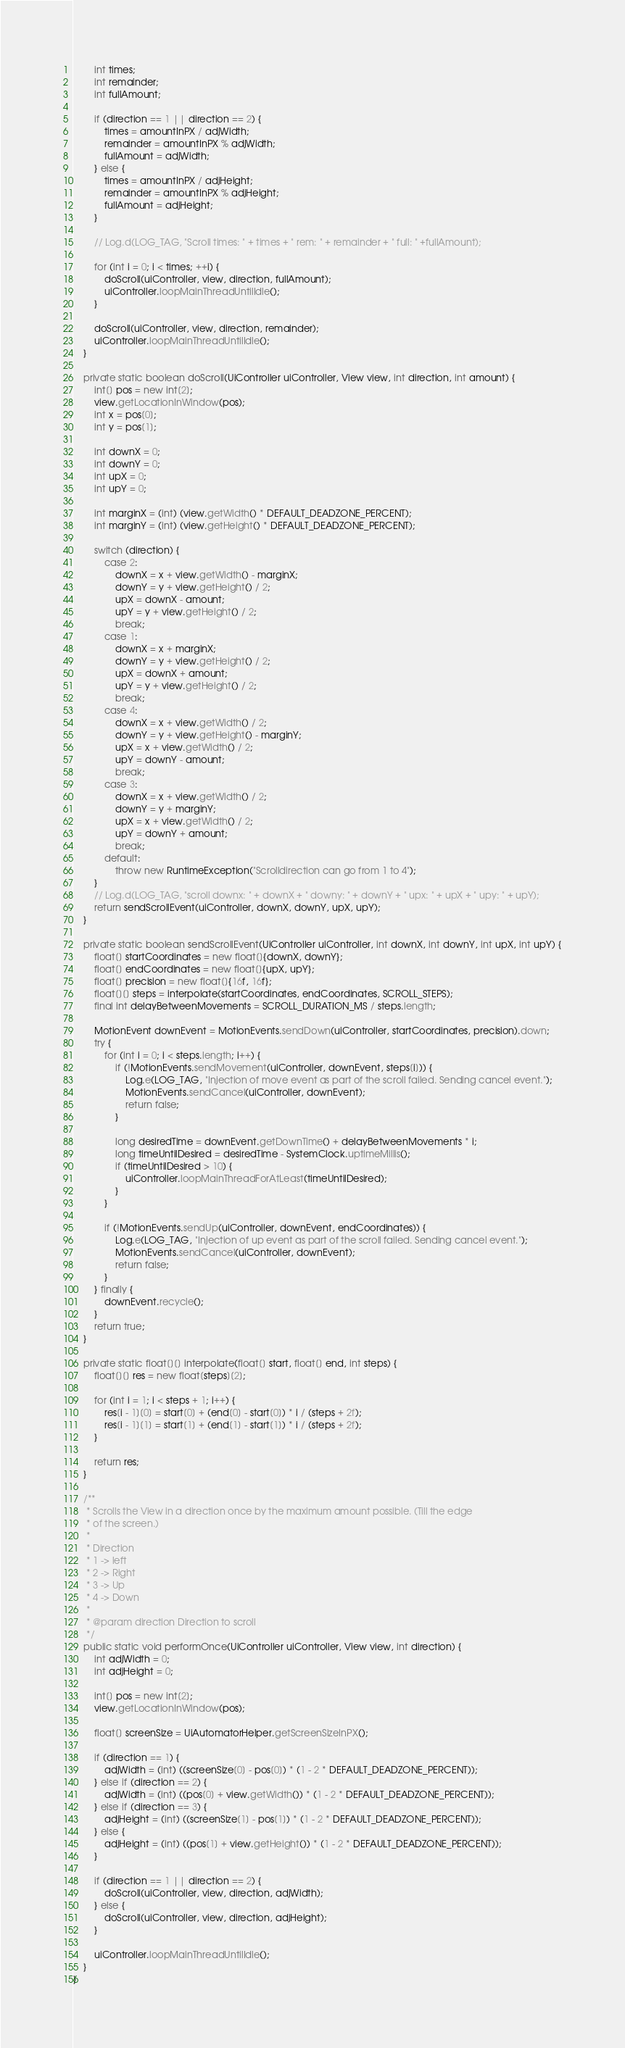Convert code to text. <code><loc_0><loc_0><loc_500><loc_500><_Java_>        int times;
        int remainder;
        int fullAmount;

        if (direction == 1 || direction == 2) {
            times = amountInPX / adjWidth;
            remainder = amountInPX % adjWidth;
            fullAmount = adjWidth;
        } else {
            times = amountInPX / adjHeight;
            remainder = amountInPX % adjHeight;
            fullAmount = adjHeight;
        }

        // Log.d(LOG_TAG, "Scroll times: " + times + " rem: " + remainder + " full: " +fullAmount);

        for (int i = 0; i < times; ++i) {
            doScroll(uiController, view, direction, fullAmount);
            uiController.loopMainThreadUntilIdle();
        }

        doScroll(uiController, view, direction, remainder);
        uiController.loopMainThreadUntilIdle();
    }

    private static boolean doScroll(UiController uiController, View view, int direction, int amount) {
        int[] pos = new int[2];
        view.getLocationInWindow(pos);
        int x = pos[0];
        int y = pos[1];

        int downX = 0;
        int downY = 0;
        int upX = 0;
        int upY = 0;

        int marginX = (int) (view.getWidth() * DEFAULT_DEADZONE_PERCENT);
        int marginY = (int) (view.getHeight() * DEFAULT_DEADZONE_PERCENT);

        switch (direction) {
            case 2:
                downX = x + view.getWidth() - marginX;
                downY = y + view.getHeight() / 2;
                upX = downX - amount;
                upY = y + view.getHeight() / 2;
                break;
            case 1:
                downX = x + marginX;
                downY = y + view.getHeight() / 2;
                upX = downX + amount;
                upY = y + view.getHeight() / 2;
                break;
            case 4:
                downX = x + view.getWidth() / 2;
                downY = y + view.getHeight() - marginY;
                upX = x + view.getWidth() / 2;
                upY = downY - amount;
                break;
            case 3:
                downX = x + view.getWidth() / 2;
                downY = y + marginY;
                upX = x + view.getWidth() / 2;
                upY = downY + amount;
                break;
            default:
                throw new RuntimeException("Scrolldirection can go from 1 to 4");
        }
        // Log.d(LOG_TAG, "scroll downx: " + downX + " downy: " + downY + " upx: " + upX + " upy: " + upY);
        return sendScrollEvent(uiController, downX, downY, upX, upY);
    }

    private static boolean sendScrollEvent(UiController uiController, int downX, int downY, int upX, int upY) {
        float[] startCoordinates = new float[]{downX, downY};
        float[] endCoordinates = new float[]{upX, upY};
        float[] precision = new float[]{16f, 16f};
        float[][] steps = interpolate(startCoordinates, endCoordinates, SCROLL_STEPS);
        final int delayBetweenMovements = SCROLL_DURATION_MS / steps.length;

        MotionEvent downEvent = MotionEvents.sendDown(uiController, startCoordinates, precision).down;
        try {
            for (int i = 0; i < steps.length; i++) {
                if (!MotionEvents.sendMovement(uiController, downEvent, steps[i])) {
                    Log.e(LOG_TAG, "Injection of move event as part of the scroll failed. Sending cancel event.");
                    MotionEvents.sendCancel(uiController, downEvent);
                    return false;
                }

                long desiredTime = downEvent.getDownTime() + delayBetweenMovements * i;
                long timeUntilDesired = desiredTime - SystemClock.uptimeMillis();
                if (timeUntilDesired > 10) {
                    uiController.loopMainThreadForAtLeast(timeUntilDesired);
                }
            }

            if (!MotionEvents.sendUp(uiController, downEvent, endCoordinates)) {
                Log.e(LOG_TAG, "Injection of up event as part of the scroll failed. Sending cancel event.");
                MotionEvents.sendCancel(uiController, downEvent);
                return false;
            }
        } finally {
            downEvent.recycle();
        }
        return true;
    }

    private static float[][] interpolate(float[] start, float[] end, int steps) {
        float[][] res = new float[steps][2];

        for (int i = 1; i < steps + 1; i++) {
            res[i - 1][0] = start[0] + (end[0] - start[0]) * i / (steps + 2f);
            res[i - 1][1] = start[1] + (end[1] - start[1]) * i / (steps + 2f);
        }

        return res;
    }

    /**
     * Scrolls the View in a direction once by the maximum amount possible. (Till the edge
     * of the screen.)
     *
     * Direction
     * 1 -> left
     * 2 -> Right
     * 3 -> Up
     * 4 -> Down
     *
     * @param direction Direction to scroll
     */
    public static void performOnce(UiController uiController, View view, int direction) {
        int adjWidth = 0;
        int adjHeight = 0;

        int[] pos = new int[2];
        view.getLocationInWindow(pos);

        float[] screenSize = UiAutomatorHelper.getScreenSizeInPX();

        if (direction == 1) {
            adjWidth = (int) ((screenSize[0] - pos[0]) * (1 - 2 * DEFAULT_DEADZONE_PERCENT));
        } else if (direction == 2) {
            adjWidth = (int) ((pos[0] + view.getWidth()) * (1 - 2 * DEFAULT_DEADZONE_PERCENT));
        } else if (direction == 3) {
            adjHeight = (int) ((screenSize[1] - pos[1]) * (1 - 2 * DEFAULT_DEADZONE_PERCENT));
        } else {
            adjHeight = (int) ((pos[1] + view.getHeight()) * (1 - 2 * DEFAULT_DEADZONE_PERCENT));
        }

        if (direction == 1 || direction == 2) {
            doScroll(uiController, view, direction, adjWidth);
        } else {
            doScroll(uiController, view, direction, adjHeight);
        }

        uiController.loopMainThreadUntilIdle();
    }
}
</code> 